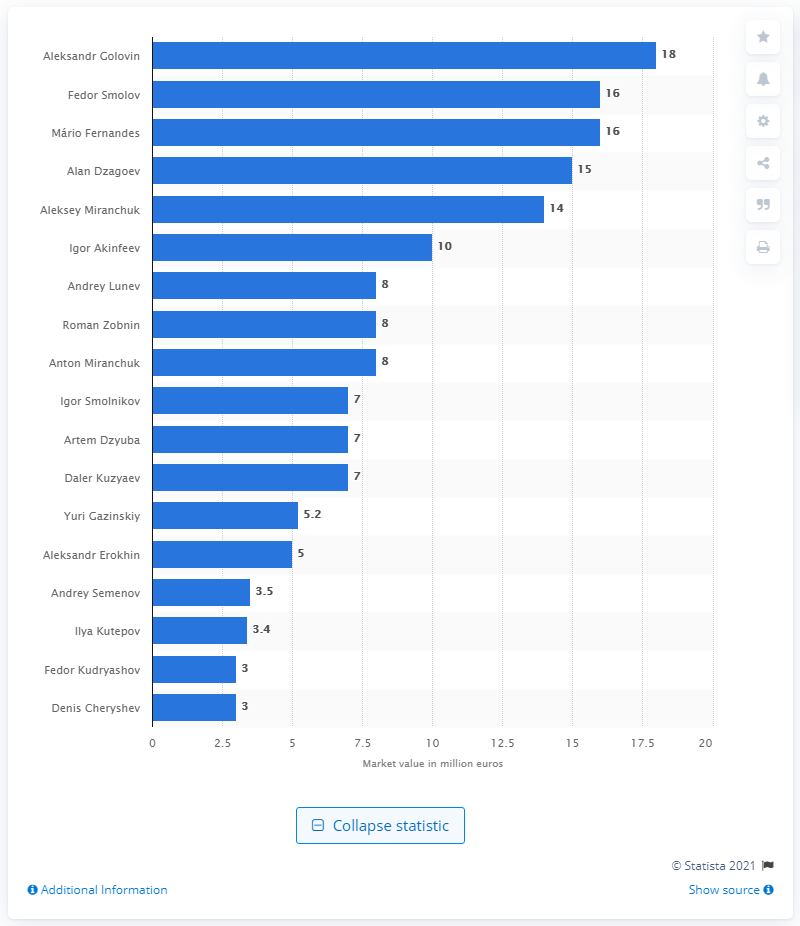Specify some key components in this picture. Aleksandr Golovin was declared the most valuable player at the 2018 FIFA World Cup. The market value of Aleksandr Golovin in 2018 was [insert value]. 